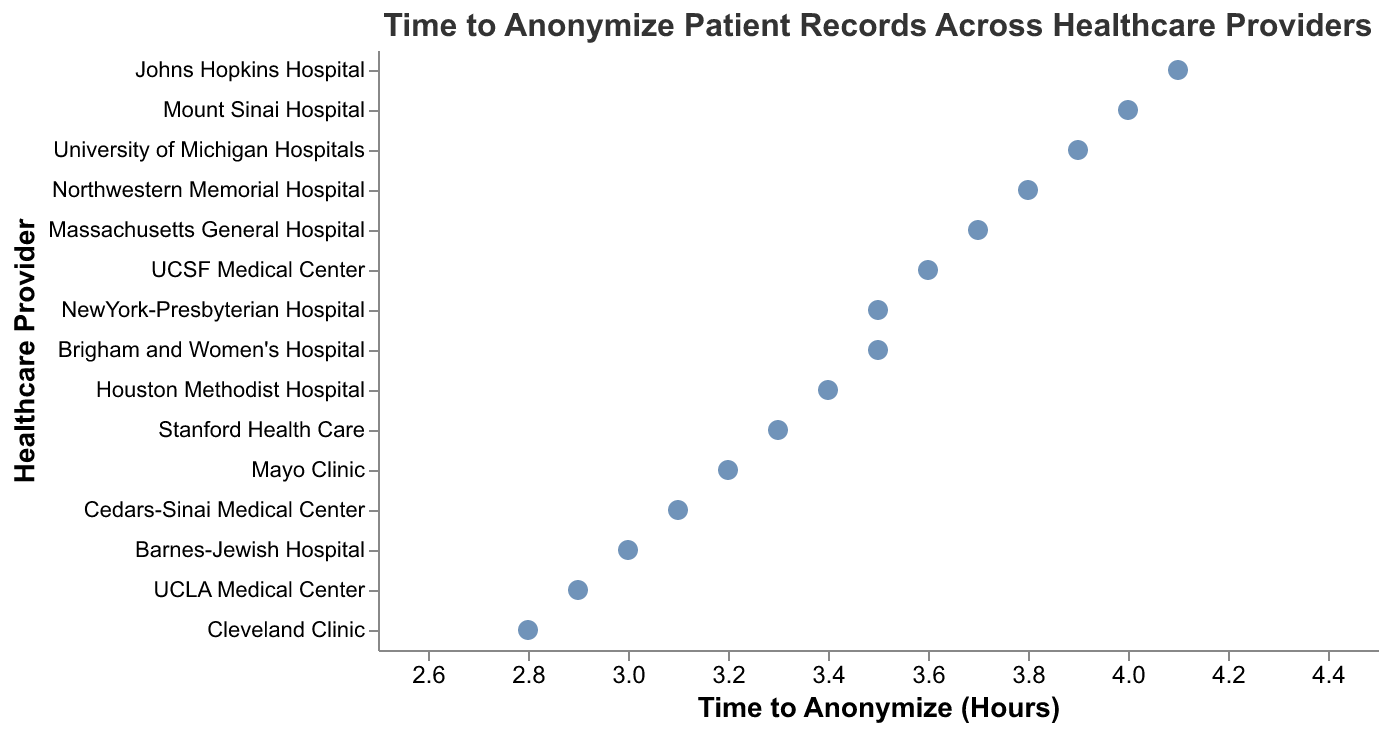What is the range of times taken to anonymize patient records among the healthcare providers? The times range from the minimum of 2.8 hours at Cleveland Clinic to the maximum of 4.1 hours at Johns Hopkins Hospital.
Answer: 2.8 to 4.1 hours Which healthcare provider took the longest time to anonymize patient records? The point farthest to the right on the x-axis indicates the longest time. Johns Hopkins Hospital took 4.1 hours.
Answer: Johns Hopkins Hospital How many healthcare providers took 3.5 hours to anonymize patient records? The plot shows two points at 3.5 hours on the x-axis, corresponding to NewYork-Presbyterian Hospital and Brigham and Women's Hospital.
Answer: 2 Which healthcare provider is more efficient, Cleveland Clinic or Mayo Clinic, in terms of anonymizing patient records? Comparing the x-axis values, Cleveland Clinic at 2.8 hours is more efficient than Mayo Clinic at 3.2 hours.
Answer: Cleveland Clinic What is the average time taken to anonymize patient records across all healthcare providers? Adding up all the times: 3.2 + 2.8 + 4.1 + 3.7 + 3.5 + 2.9 + 3.3 + 4.0 + 3.6 + 3.8 + 3.1 + 3.4 + 3.9 + 3.0 + 3.5 = 52.8 hours. Dividing by 15 providers, the average is 52.8 / 15 ≈ 3.52 hours.
Answer: 3.52 hours Which provider has a time closest to the average time taken to anonymize patient records? The average time is approximately 3.52 hours. The provider with a time closest to this is NewYork-Presbyterian Hospital and Brigham and Women's Hospital at 3.5 hours.
Answer: NewYork-Presbyterian Hospital and Brigham and Women's Hospital What is the difference in hours to anonymize patient records between the fastest and slowest healthcare providers? The fastest is Cleveland Clinic at 2.8 hours, and the slowest is Johns Hopkins Hospital at 4.1 hours. The difference is 4.1 - 2.8 = 1.3 hours.
Answer: 1.3 hours Which providers have times that fall below the average time taken of 3.52 hours? Providers with times less than 3.52 hours are: Cleveland Clinic (2.8), UCLA Medical Center (2.9), Cedars-Sinai Medical Center (3.1), Barnes-Jewish Hospital (3.0), and Mayo Clinic (3.2).
Answer: Cleveland Clinic, UCLA Medical Center, Cedars-Sinai Medical Center, Barnes-Jewish Hospital, and Mayo Clinic Is there a significant clustering of providers around a particular time value? By observing the distribution of points, there seems to be multiple providers clustering around the 3.5 to 4.0 hour range.
Answer: Yes Which provider has a time closest to 3.0 hours? The point closest to 3.0 hours on the x-axis belongs to Barnes-Jewish Hospital with a time of exactly 3.0 hours.
Answer: Barnes-Jewish Hospital 